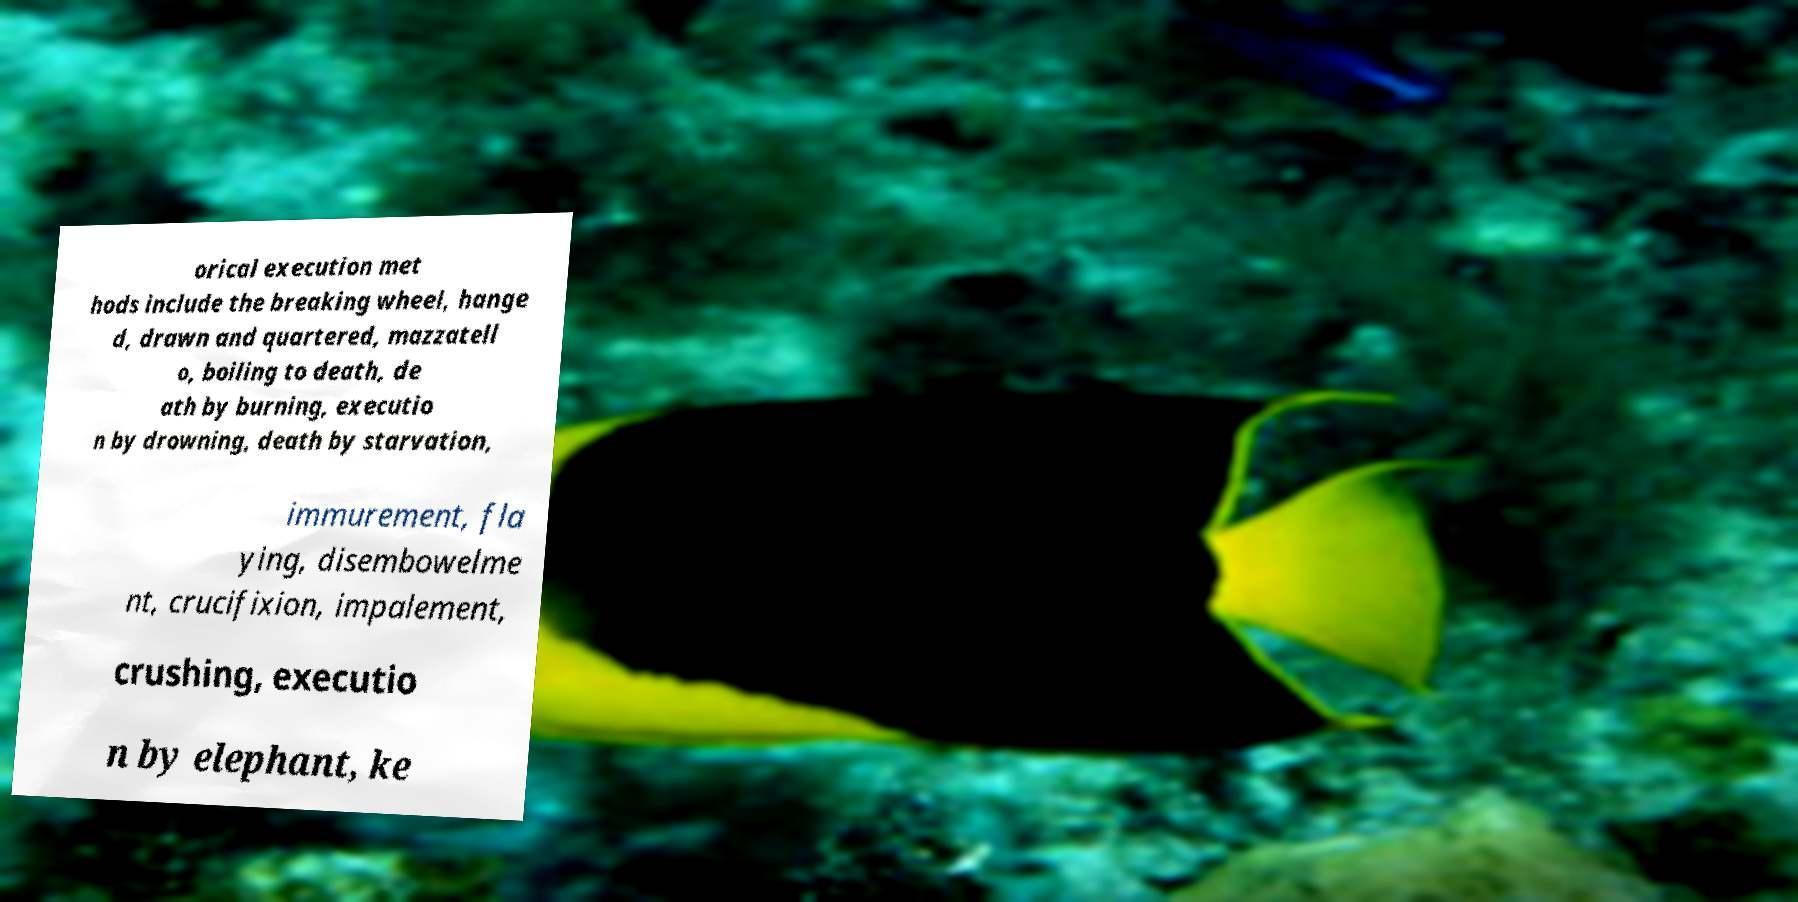Could you assist in decoding the text presented in this image and type it out clearly? orical execution met hods include the breaking wheel, hange d, drawn and quartered, mazzatell o, boiling to death, de ath by burning, executio n by drowning, death by starvation, immurement, fla ying, disembowelme nt, crucifixion, impalement, crushing, executio n by elephant, ke 